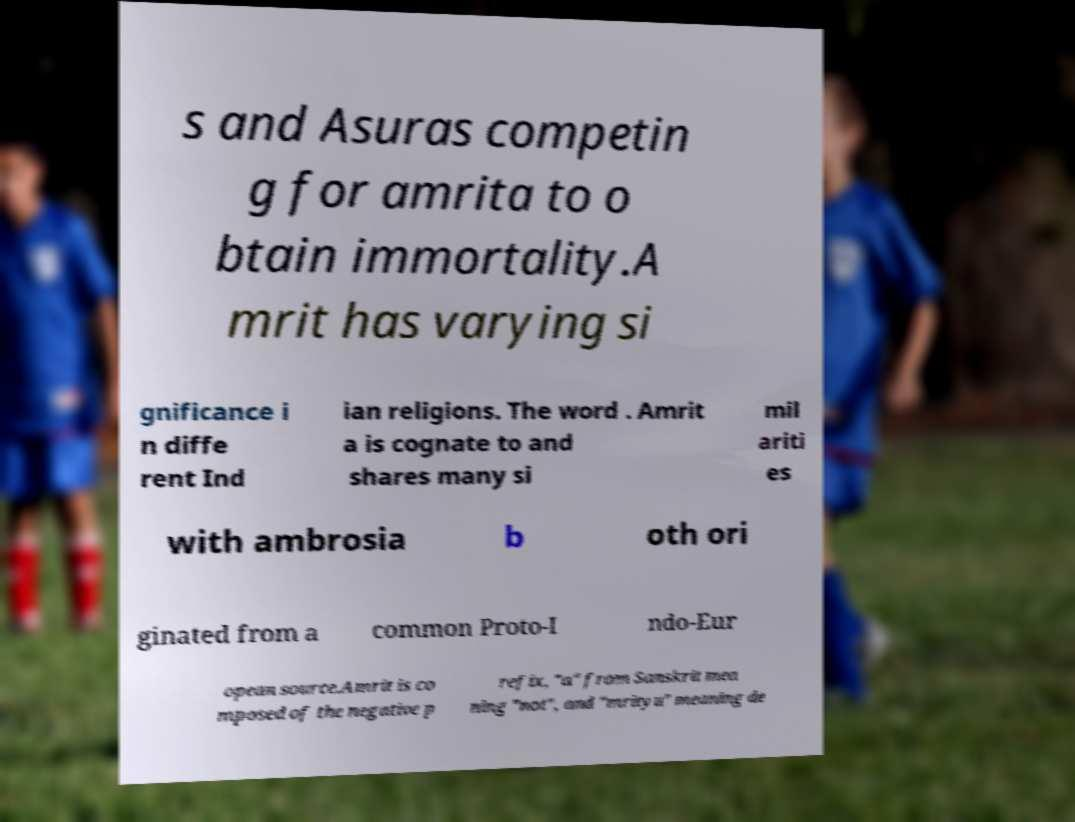For documentation purposes, I need the text within this image transcribed. Could you provide that? s and Asuras competin g for amrita to o btain immortality.A mrit has varying si gnificance i n diffe rent Ind ian religions. The word . Amrit a is cognate to and shares many si mil ariti es with ambrosia b oth ori ginated from a common Proto-I ndo-Eur opean source.Amrit is co mposed of the negative p refix, "a" from Sanskrit mea ning "not", and "mrityu" meaning de 